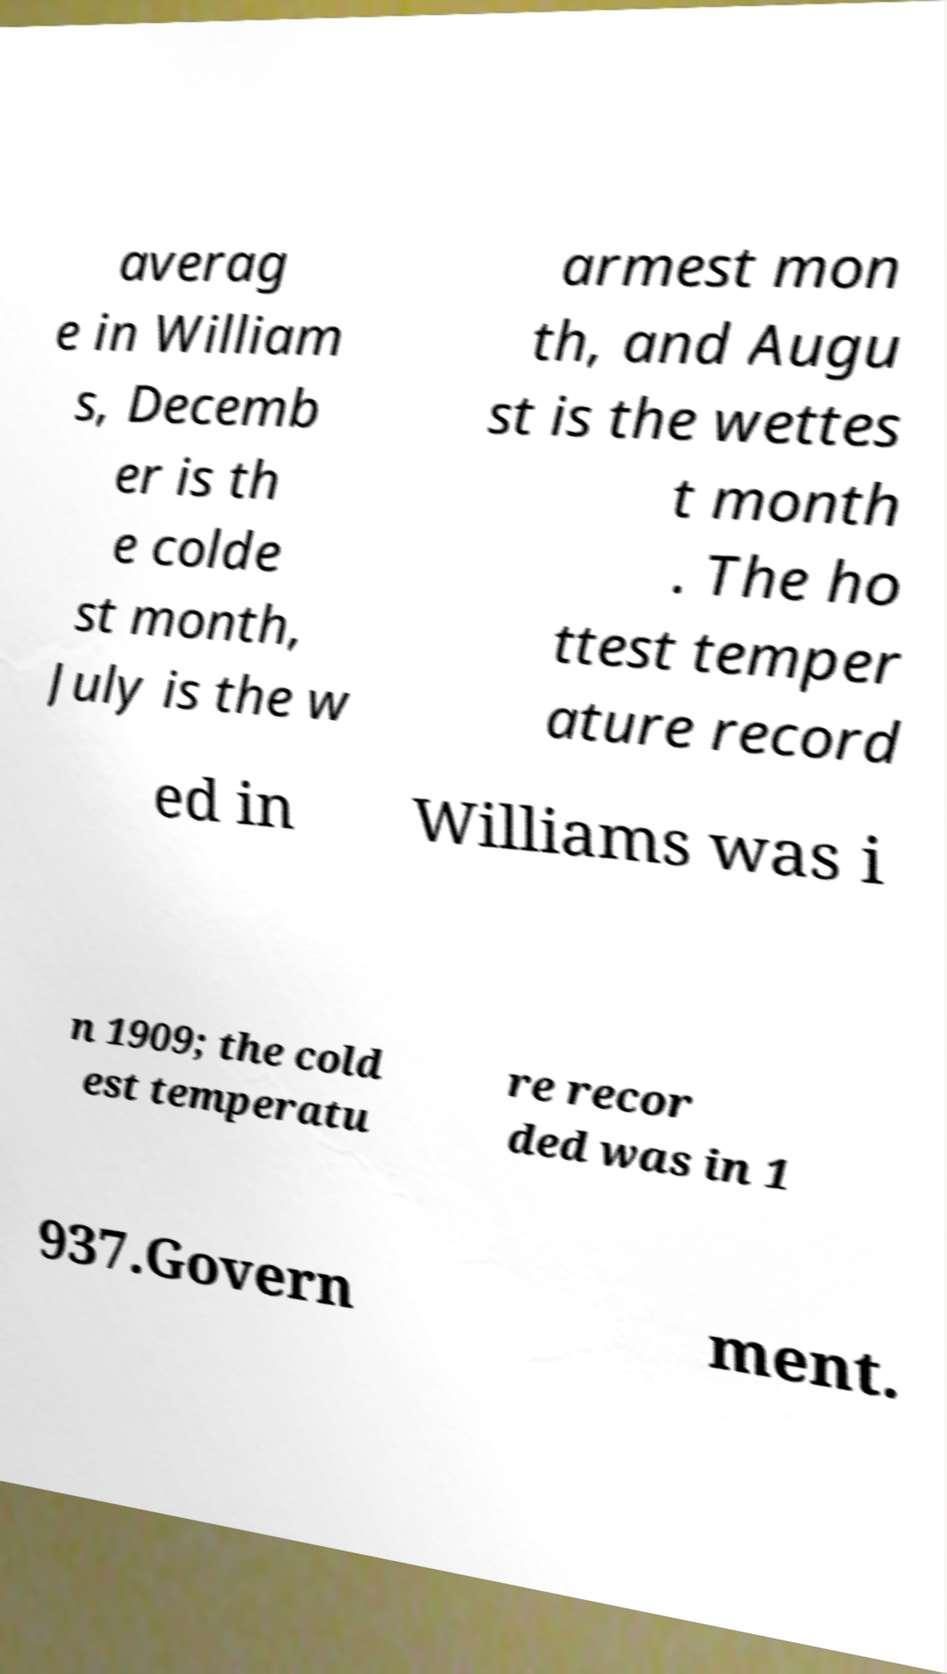There's text embedded in this image that I need extracted. Can you transcribe it verbatim? averag e in William s, Decemb er is th e colde st month, July is the w armest mon th, and Augu st is the wettes t month . The ho ttest temper ature record ed in Williams was i n 1909; the cold est temperatu re recor ded was in 1 937.Govern ment. 